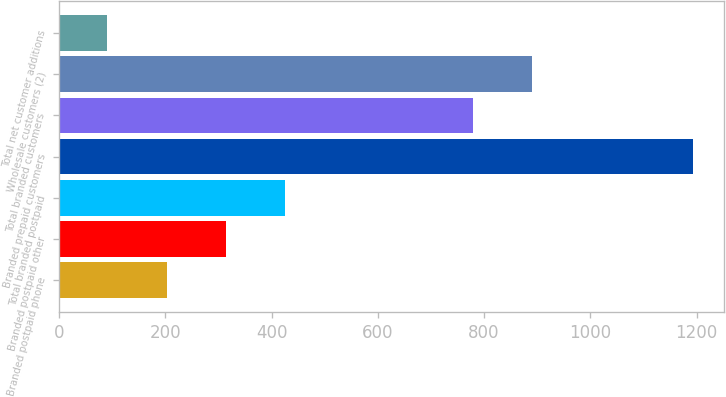Convert chart to OTSL. <chart><loc_0><loc_0><loc_500><loc_500><bar_chart><fcel>Branded postpaid phone<fcel>Branded postpaid other<fcel>Total branded postpaid<fcel>Branded prepaid customers<fcel>Total branded customers<fcel>Wholesale customers (2)<fcel>Total net customer additions<nl><fcel>204<fcel>314.2<fcel>424.4<fcel>1193<fcel>780<fcel>890.2<fcel>91<nl></chart> 